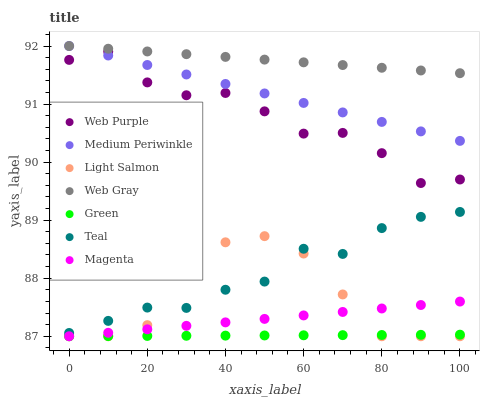Does Green have the minimum area under the curve?
Answer yes or no. Yes. Does Web Gray have the maximum area under the curve?
Answer yes or no. Yes. Does Medium Periwinkle have the minimum area under the curve?
Answer yes or no. No. Does Medium Periwinkle have the maximum area under the curve?
Answer yes or no. No. Is Green the smoothest?
Answer yes or no. Yes. Is Light Salmon the roughest?
Answer yes or no. Yes. Is Web Gray the smoothest?
Answer yes or no. No. Is Web Gray the roughest?
Answer yes or no. No. Does Light Salmon have the lowest value?
Answer yes or no. Yes. Does Medium Periwinkle have the lowest value?
Answer yes or no. No. Does Medium Periwinkle have the highest value?
Answer yes or no. Yes. Does Web Purple have the highest value?
Answer yes or no. No. Is Light Salmon less than Medium Periwinkle?
Answer yes or no. Yes. Is Medium Periwinkle greater than Teal?
Answer yes or no. Yes. Does Light Salmon intersect Magenta?
Answer yes or no. Yes. Is Light Salmon less than Magenta?
Answer yes or no. No. Is Light Salmon greater than Magenta?
Answer yes or no. No. Does Light Salmon intersect Medium Periwinkle?
Answer yes or no. No. 